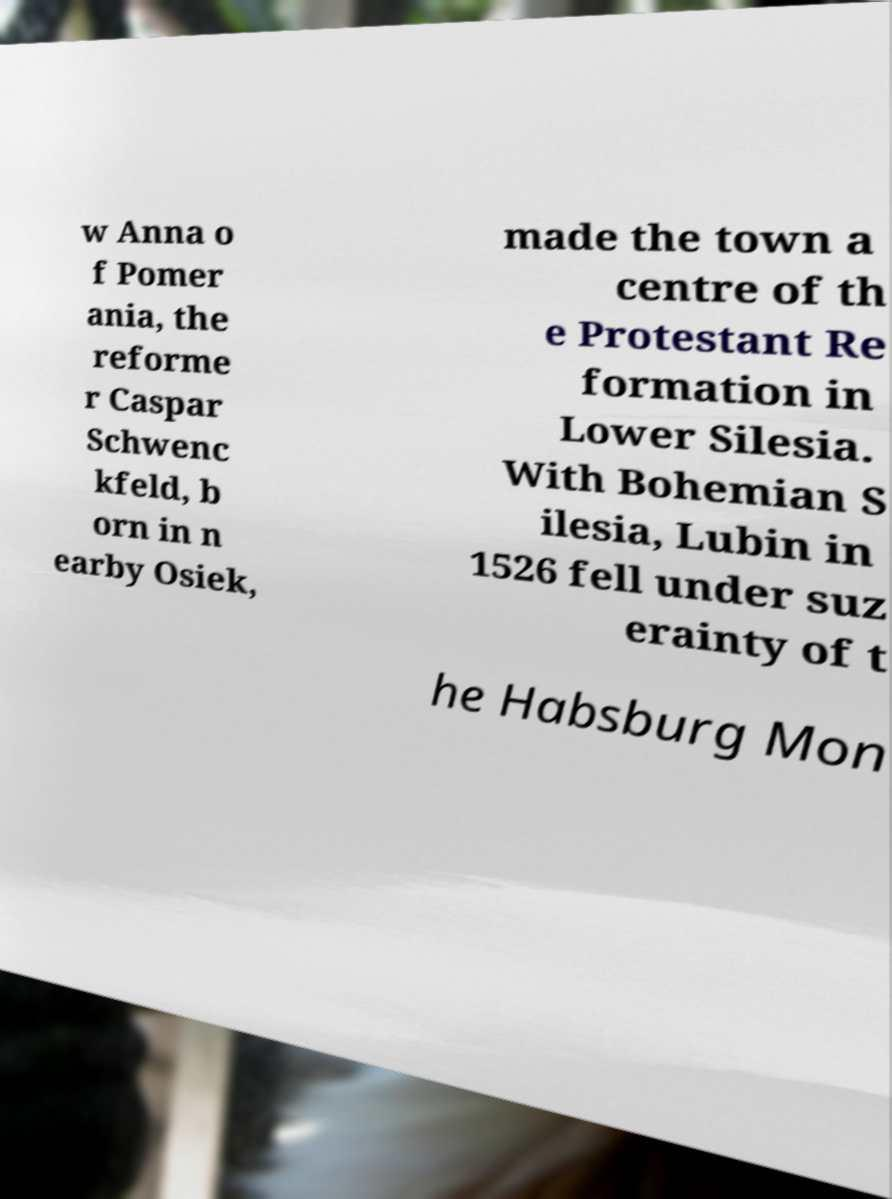Can you accurately transcribe the text from the provided image for me? w Anna o f Pomer ania, the reforme r Caspar Schwenc kfeld, b orn in n earby Osiek, made the town a centre of th e Protestant Re formation in Lower Silesia. With Bohemian S ilesia, Lubin in 1526 fell under suz erainty of t he Habsburg Mon 